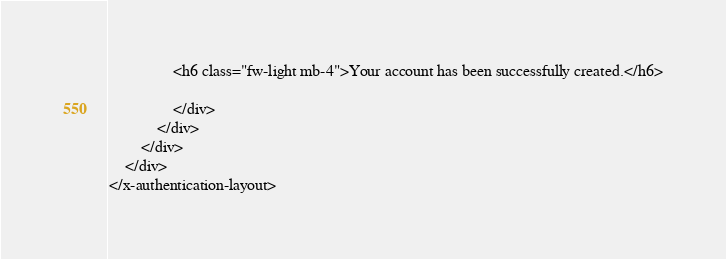<code> <loc_0><loc_0><loc_500><loc_500><_PHP_>                <h6 class="fw-light mb-4">Your account has been successfully created.</h6>

                </div>
            </div>
        </div>
    </div>
</x-authentication-layout>
</code> 